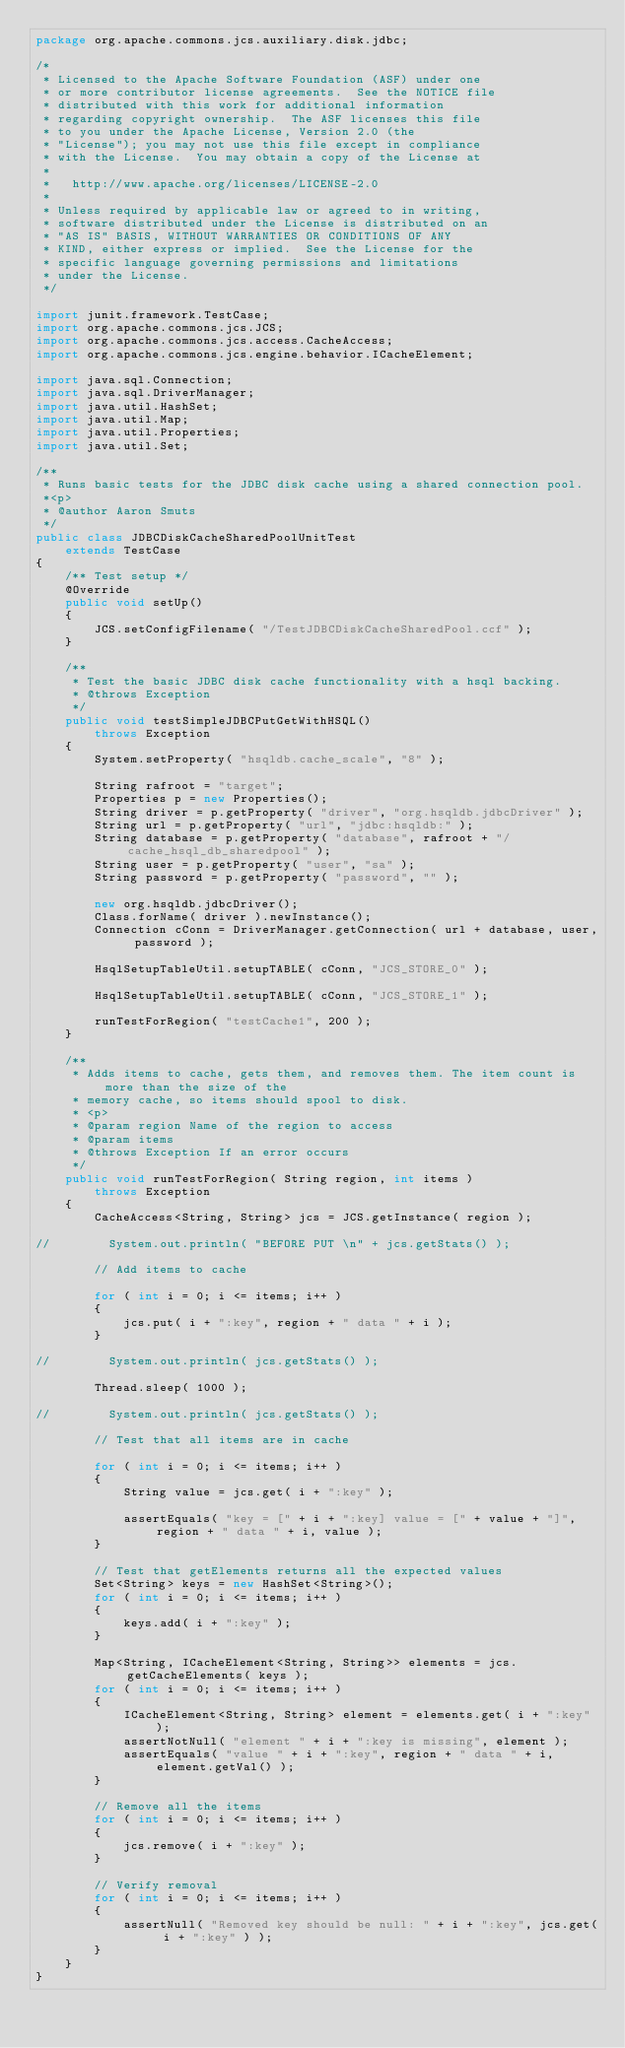<code> <loc_0><loc_0><loc_500><loc_500><_Java_>package org.apache.commons.jcs.auxiliary.disk.jdbc;

/*
 * Licensed to the Apache Software Foundation (ASF) under one
 * or more contributor license agreements.  See the NOTICE file
 * distributed with this work for additional information
 * regarding copyright ownership.  The ASF licenses this file
 * to you under the Apache License, Version 2.0 (the
 * "License"); you may not use this file except in compliance
 * with the License.  You may obtain a copy of the License at
 *
 *   http://www.apache.org/licenses/LICENSE-2.0
 *
 * Unless required by applicable law or agreed to in writing,
 * software distributed under the License is distributed on an
 * "AS IS" BASIS, WITHOUT WARRANTIES OR CONDITIONS OF ANY
 * KIND, either express or implied.  See the License for the
 * specific language governing permissions and limitations
 * under the License.
 */

import junit.framework.TestCase;
import org.apache.commons.jcs.JCS;
import org.apache.commons.jcs.access.CacheAccess;
import org.apache.commons.jcs.engine.behavior.ICacheElement;

import java.sql.Connection;
import java.sql.DriverManager;
import java.util.HashSet;
import java.util.Map;
import java.util.Properties;
import java.util.Set;

/**
 * Runs basic tests for the JDBC disk cache using a shared connection pool.
 *<p>
 * @author Aaron Smuts
 */
public class JDBCDiskCacheSharedPoolUnitTest
    extends TestCase
{
    /** Test setup */
    @Override
    public void setUp()
    {
        JCS.setConfigFilename( "/TestJDBCDiskCacheSharedPool.ccf" );
    }

    /**
     * Test the basic JDBC disk cache functionality with a hsql backing.
     * @throws Exception
     */
    public void testSimpleJDBCPutGetWithHSQL()
        throws Exception
    {
        System.setProperty( "hsqldb.cache_scale", "8" );

        String rafroot = "target";
        Properties p = new Properties();
        String driver = p.getProperty( "driver", "org.hsqldb.jdbcDriver" );
        String url = p.getProperty( "url", "jdbc:hsqldb:" );
        String database = p.getProperty( "database", rafroot + "/cache_hsql_db_sharedpool" );
        String user = p.getProperty( "user", "sa" );
        String password = p.getProperty( "password", "" );

        new org.hsqldb.jdbcDriver();
        Class.forName( driver ).newInstance();
        Connection cConn = DriverManager.getConnection( url + database, user, password );

        HsqlSetupTableUtil.setupTABLE( cConn, "JCS_STORE_0" );

        HsqlSetupTableUtil.setupTABLE( cConn, "JCS_STORE_1" );

        runTestForRegion( "testCache1", 200 );
    }

    /**
     * Adds items to cache, gets them, and removes them. The item count is more than the size of the
     * memory cache, so items should spool to disk.
     * <p>
     * @param region Name of the region to access
     * @param items
     * @throws Exception If an error occurs
     */
    public void runTestForRegion( String region, int items )
        throws Exception
    {
        CacheAccess<String, String> jcs = JCS.getInstance( region );

//        System.out.println( "BEFORE PUT \n" + jcs.getStats() );

        // Add items to cache

        for ( int i = 0; i <= items; i++ )
        {
            jcs.put( i + ":key", region + " data " + i );
        }

//        System.out.println( jcs.getStats() );

        Thread.sleep( 1000 );

//        System.out.println( jcs.getStats() );

        // Test that all items are in cache

        for ( int i = 0; i <= items; i++ )
        {
            String value = jcs.get( i + ":key" );

            assertEquals( "key = [" + i + ":key] value = [" + value + "]", region + " data " + i, value );
        }

        // Test that getElements returns all the expected values
        Set<String> keys = new HashSet<String>();
        for ( int i = 0; i <= items; i++ )
        {
            keys.add( i + ":key" );
        }

        Map<String, ICacheElement<String, String>> elements = jcs.getCacheElements( keys );
        for ( int i = 0; i <= items; i++ )
        {
            ICacheElement<String, String> element = elements.get( i + ":key" );
            assertNotNull( "element " + i + ":key is missing", element );
            assertEquals( "value " + i + ":key", region + " data " + i, element.getVal() );
        }

        // Remove all the items
        for ( int i = 0; i <= items; i++ )
        {
            jcs.remove( i + ":key" );
        }

        // Verify removal
        for ( int i = 0; i <= items; i++ )
        {
            assertNull( "Removed key should be null: " + i + ":key", jcs.get( i + ":key" ) );
        }
    }
}
</code> 